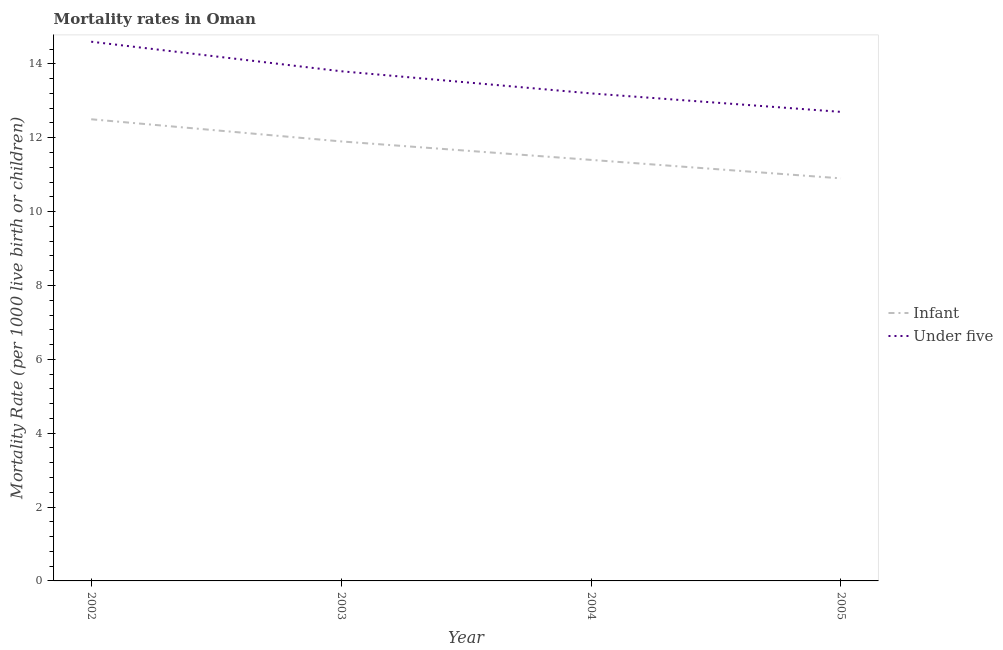How many different coloured lines are there?
Your response must be concise. 2. Does the line corresponding to under-5 mortality rate intersect with the line corresponding to infant mortality rate?
Make the answer very short. No. Is the number of lines equal to the number of legend labels?
Your answer should be compact. Yes. What is the under-5 mortality rate in 2005?
Your answer should be compact. 12.7. Across all years, what is the maximum under-5 mortality rate?
Offer a very short reply. 14.6. In which year was the under-5 mortality rate maximum?
Ensure brevity in your answer.  2002. In which year was the under-5 mortality rate minimum?
Make the answer very short. 2005. What is the total under-5 mortality rate in the graph?
Provide a succinct answer. 54.3. What is the difference between the under-5 mortality rate in 2002 and that in 2003?
Ensure brevity in your answer.  0.8. What is the difference between the infant mortality rate in 2003 and the under-5 mortality rate in 2005?
Keep it short and to the point. -0.8. What is the average infant mortality rate per year?
Offer a terse response. 11.67. In the year 2004, what is the difference between the under-5 mortality rate and infant mortality rate?
Provide a succinct answer. 1.8. In how many years, is the under-5 mortality rate greater than 3.2?
Provide a short and direct response. 4. What is the ratio of the under-5 mortality rate in 2002 to that in 2004?
Your answer should be very brief. 1.11. What is the difference between the highest and the second highest under-5 mortality rate?
Provide a succinct answer. 0.8. What is the difference between the highest and the lowest under-5 mortality rate?
Your response must be concise. 1.9. Does the under-5 mortality rate monotonically increase over the years?
Provide a succinct answer. No. Is the under-5 mortality rate strictly less than the infant mortality rate over the years?
Make the answer very short. No. How many lines are there?
Offer a very short reply. 2. How many years are there in the graph?
Offer a terse response. 4. What is the difference between two consecutive major ticks on the Y-axis?
Provide a short and direct response. 2. Does the graph contain grids?
Your response must be concise. No. How many legend labels are there?
Offer a terse response. 2. What is the title of the graph?
Your response must be concise. Mortality rates in Oman. Does "Arms exports" appear as one of the legend labels in the graph?
Your response must be concise. No. What is the label or title of the Y-axis?
Ensure brevity in your answer.  Mortality Rate (per 1000 live birth or children). What is the Mortality Rate (per 1000 live birth or children) in Under five in 2004?
Make the answer very short. 13.2. What is the Mortality Rate (per 1000 live birth or children) in Under five in 2005?
Give a very brief answer. 12.7. Across all years, what is the maximum Mortality Rate (per 1000 live birth or children) in Infant?
Provide a succinct answer. 12.5. Across all years, what is the maximum Mortality Rate (per 1000 live birth or children) in Under five?
Your answer should be compact. 14.6. Across all years, what is the minimum Mortality Rate (per 1000 live birth or children) in Under five?
Make the answer very short. 12.7. What is the total Mortality Rate (per 1000 live birth or children) in Infant in the graph?
Your answer should be compact. 46.7. What is the total Mortality Rate (per 1000 live birth or children) in Under five in the graph?
Ensure brevity in your answer.  54.3. What is the difference between the Mortality Rate (per 1000 live birth or children) in Infant in 2002 and that in 2004?
Provide a short and direct response. 1.1. What is the difference between the Mortality Rate (per 1000 live birth or children) of Infant in 2002 and that in 2005?
Your answer should be very brief. 1.6. What is the difference between the Mortality Rate (per 1000 live birth or children) of Under five in 2002 and that in 2005?
Give a very brief answer. 1.9. What is the difference between the Mortality Rate (per 1000 live birth or children) of Infant in 2003 and that in 2004?
Your response must be concise. 0.5. What is the difference between the Mortality Rate (per 1000 live birth or children) in Infant in 2002 and the Mortality Rate (per 1000 live birth or children) in Under five in 2004?
Your response must be concise. -0.7. What is the difference between the Mortality Rate (per 1000 live birth or children) in Infant in 2003 and the Mortality Rate (per 1000 live birth or children) in Under five in 2004?
Your response must be concise. -1.3. What is the average Mortality Rate (per 1000 live birth or children) in Infant per year?
Provide a succinct answer. 11.68. What is the average Mortality Rate (per 1000 live birth or children) of Under five per year?
Provide a succinct answer. 13.57. In the year 2005, what is the difference between the Mortality Rate (per 1000 live birth or children) in Infant and Mortality Rate (per 1000 live birth or children) in Under five?
Your answer should be very brief. -1.8. What is the ratio of the Mortality Rate (per 1000 live birth or children) of Infant in 2002 to that in 2003?
Offer a very short reply. 1.05. What is the ratio of the Mortality Rate (per 1000 live birth or children) of Under five in 2002 to that in 2003?
Your response must be concise. 1.06. What is the ratio of the Mortality Rate (per 1000 live birth or children) of Infant in 2002 to that in 2004?
Your answer should be compact. 1.1. What is the ratio of the Mortality Rate (per 1000 live birth or children) in Under five in 2002 to that in 2004?
Provide a short and direct response. 1.11. What is the ratio of the Mortality Rate (per 1000 live birth or children) in Infant in 2002 to that in 2005?
Offer a very short reply. 1.15. What is the ratio of the Mortality Rate (per 1000 live birth or children) of Under five in 2002 to that in 2005?
Make the answer very short. 1.15. What is the ratio of the Mortality Rate (per 1000 live birth or children) of Infant in 2003 to that in 2004?
Provide a short and direct response. 1.04. What is the ratio of the Mortality Rate (per 1000 live birth or children) of Under five in 2003 to that in 2004?
Offer a very short reply. 1.05. What is the ratio of the Mortality Rate (per 1000 live birth or children) of Infant in 2003 to that in 2005?
Provide a succinct answer. 1.09. What is the ratio of the Mortality Rate (per 1000 live birth or children) in Under five in 2003 to that in 2005?
Offer a terse response. 1.09. What is the ratio of the Mortality Rate (per 1000 live birth or children) of Infant in 2004 to that in 2005?
Your response must be concise. 1.05. What is the ratio of the Mortality Rate (per 1000 live birth or children) of Under five in 2004 to that in 2005?
Give a very brief answer. 1.04. What is the difference between the highest and the lowest Mortality Rate (per 1000 live birth or children) in Infant?
Make the answer very short. 1.6. What is the difference between the highest and the lowest Mortality Rate (per 1000 live birth or children) in Under five?
Offer a very short reply. 1.9. 